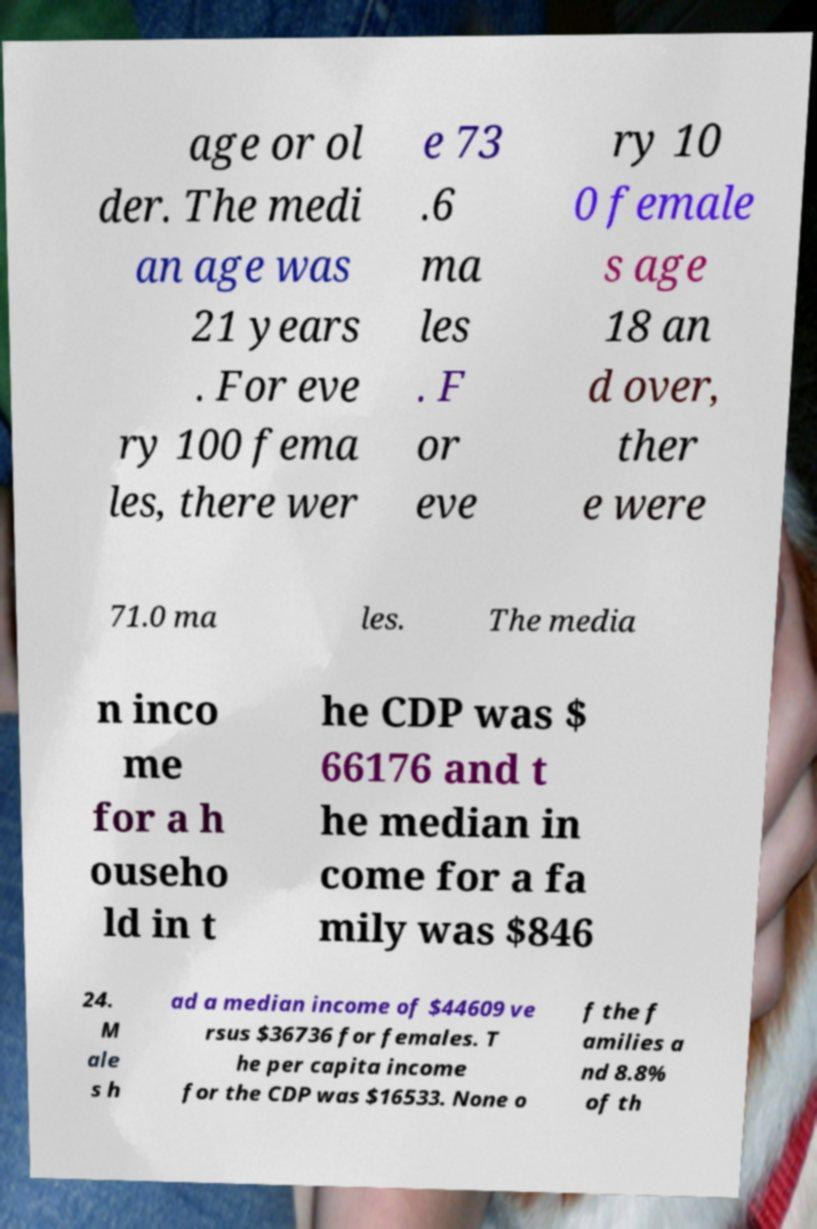Please read and relay the text visible in this image. What does it say? age or ol der. The medi an age was 21 years . For eve ry 100 fema les, there wer e 73 .6 ma les . F or eve ry 10 0 female s age 18 an d over, ther e were 71.0 ma les. The media n inco me for a h ouseho ld in t he CDP was $ 66176 and t he median in come for a fa mily was $846 24. M ale s h ad a median income of $44609 ve rsus $36736 for females. T he per capita income for the CDP was $16533. None o f the f amilies a nd 8.8% of th 